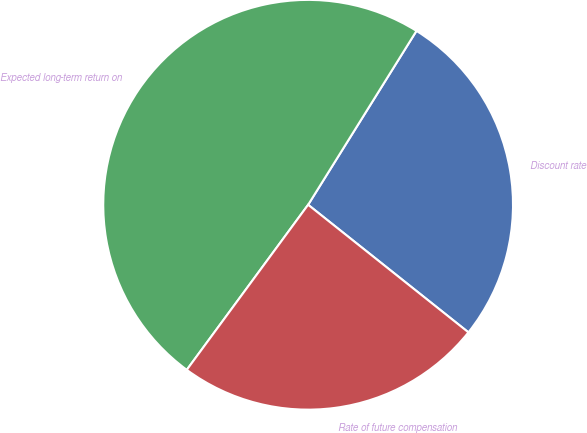Convert chart to OTSL. <chart><loc_0><loc_0><loc_500><loc_500><pie_chart><fcel>Discount rate<fcel>Expected long-term return on<fcel>Rate of future compensation<nl><fcel>26.83%<fcel>48.78%<fcel>24.39%<nl></chart> 